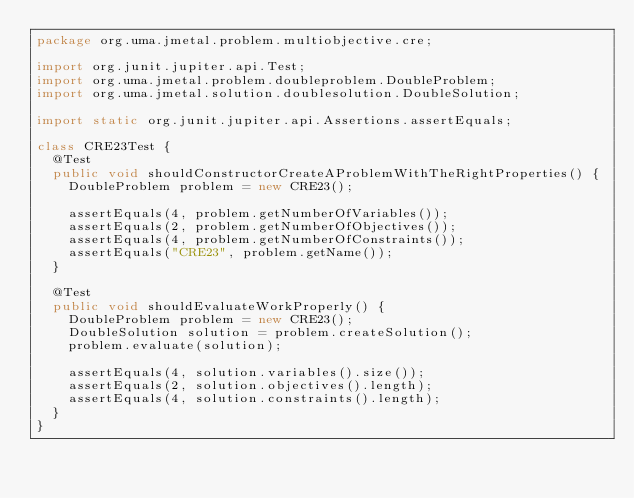Convert code to text. <code><loc_0><loc_0><loc_500><loc_500><_Java_>package org.uma.jmetal.problem.multiobjective.cre;

import org.junit.jupiter.api.Test;
import org.uma.jmetal.problem.doubleproblem.DoubleProblem;
import org.uma.jmetal.solution.doublesolution.DoubleSolution;

import static org.junit.jupiter.api.Assertions.assertEquals;

class CRE23Test {
  @Test
  public void shouldConstructorCreateAProblemWithTheRightProperties() {
    DoubleProblem problem = new CRE23();

    assertEquals(4, problem.getNumberOfVariables());
    assertEquals(2, problem.getNumberOfObjectives());
    assertEquals(4, problem.getNumberOfConstraints());
    assertEquals("CRE23", problem.getName());
  }

  @Test
  public void shouldEvaluateWorkProperly() {
    DoubleProblem problem = new CRE23();
    DoubleSolution solution = problem.createSolution();
    problem.evaluate(solution);

    assertEquals(4, solution.variables().size());
    assertEquals(2, solution.objectives().length);
    assertEquals(4, solution.constraints().length);
  }
}
</code> 